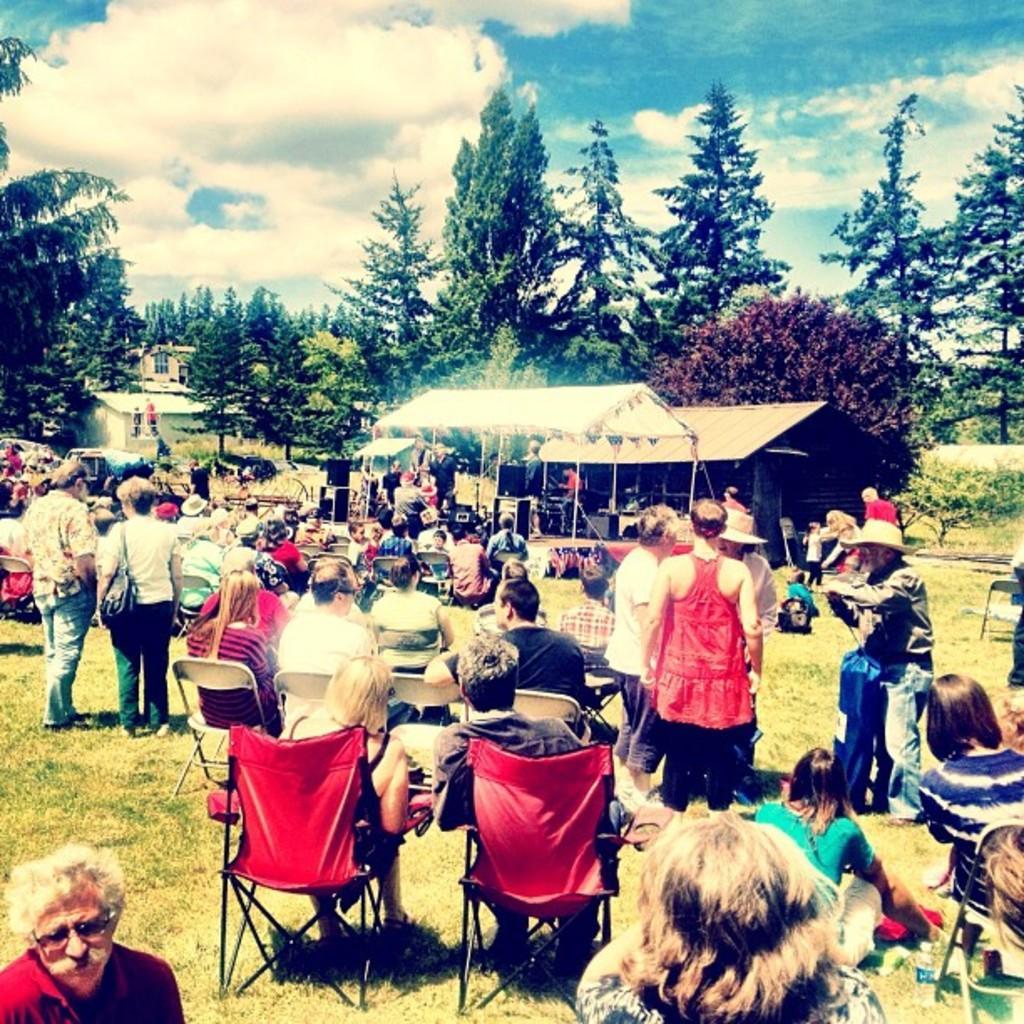In one or two sentences, can you explain what this image depicts? In this image we can see a group of persons in a grassy land and among them few people are sitting on chairs. We can see a stage and a shed. On the stage we can see few persons, speakers and musical instruments. Behind the persons we can see vehicles, plants, trees and houses. At the top we can see the sky. 